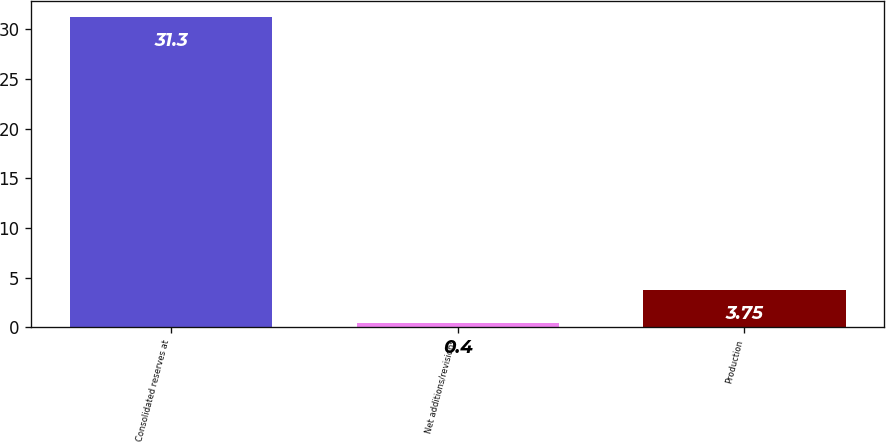Convert chart to OTSL. <chart><loc_0><loc_0><loc_500><loc_500><bar_chart><fcel>Consolidated reserves at<fcel>Net additions/revisions<fcel>Production<nl><fcel>31.3<fcel>0.4<fcel>3.75<nl></chart> 